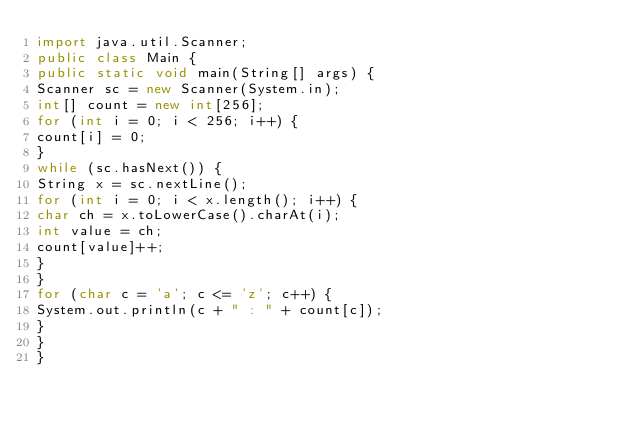Convert code to text. <code><loc_0><loc_0><loc_500><loc_500><_Java_>import java.util.Scanner;
public class Main {
public static void main(String[] args) {
Scanner sc = new Scanner(System.in);
int[] count = new int[256];
for (int i = 0; i < 256; i++) {
count[i] = 0;
}
while (sc.hasNext()) {
String x = sc.nextLine();
for (int i = 0; i < x.length(); i++) {
char ch = x.toLowerCase().charAt(i);
int value = ch;
count[value]++;
}
}
for (char c = 'a'; c <= 'z'; c++) {
System.out.println(c + " : " + count[c]);
}
}
}</code> 